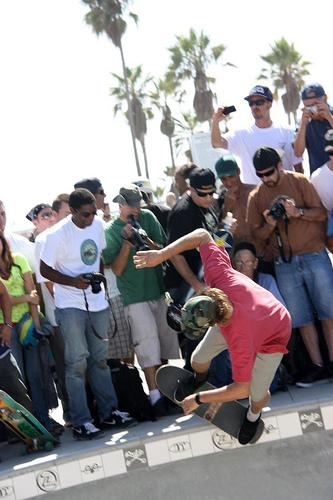What are people filming and taking pictures of? skateboarding 